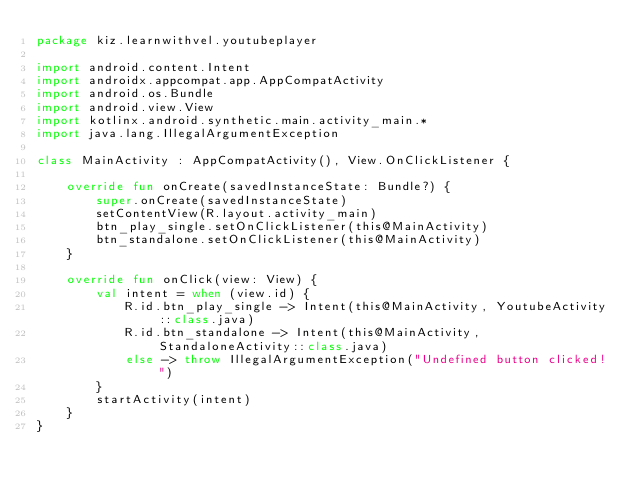Convert code to text. <code><loc_0><loc_0><loc_500><loc_500><_Kotlin_>package kiz.learnwithvel.youtubeplayer

import android.content.Intent
import androidx.appcompat.app.AppCompatActivity
import android.os.Bundle
import android.view.View
import kotlinx.android.synthetic.main.activity_main.*
import java.lang.IllegalArgumentException

class MainActivity : AppCompatActivity(), View.OnClickListener {

    override fun onCreate(savedInstanceState: Bundle?) {
        super.onCreate(savedInstanceState)
        setContentView(R.layout.activity_main)
        btn_play_single.setOnClickListener(this@MainActivity)
        btn_standalone.setOnClickListener(this@MainActivity)
    }

    override fun onClick(view: View) {
        val intent = when (view.id) {
            R.id.btn_play_single -> Intent(this@MainActivity, YoutubeActivity::class.java)
            R.id.btn_standalone -> Intent(this@MainActivity, StandaloneActivity::class.java)
            else -> throw IllegalArgumentException("Undefined button clicked!")
        }
        startActivity(intent)
    }
}</code> 